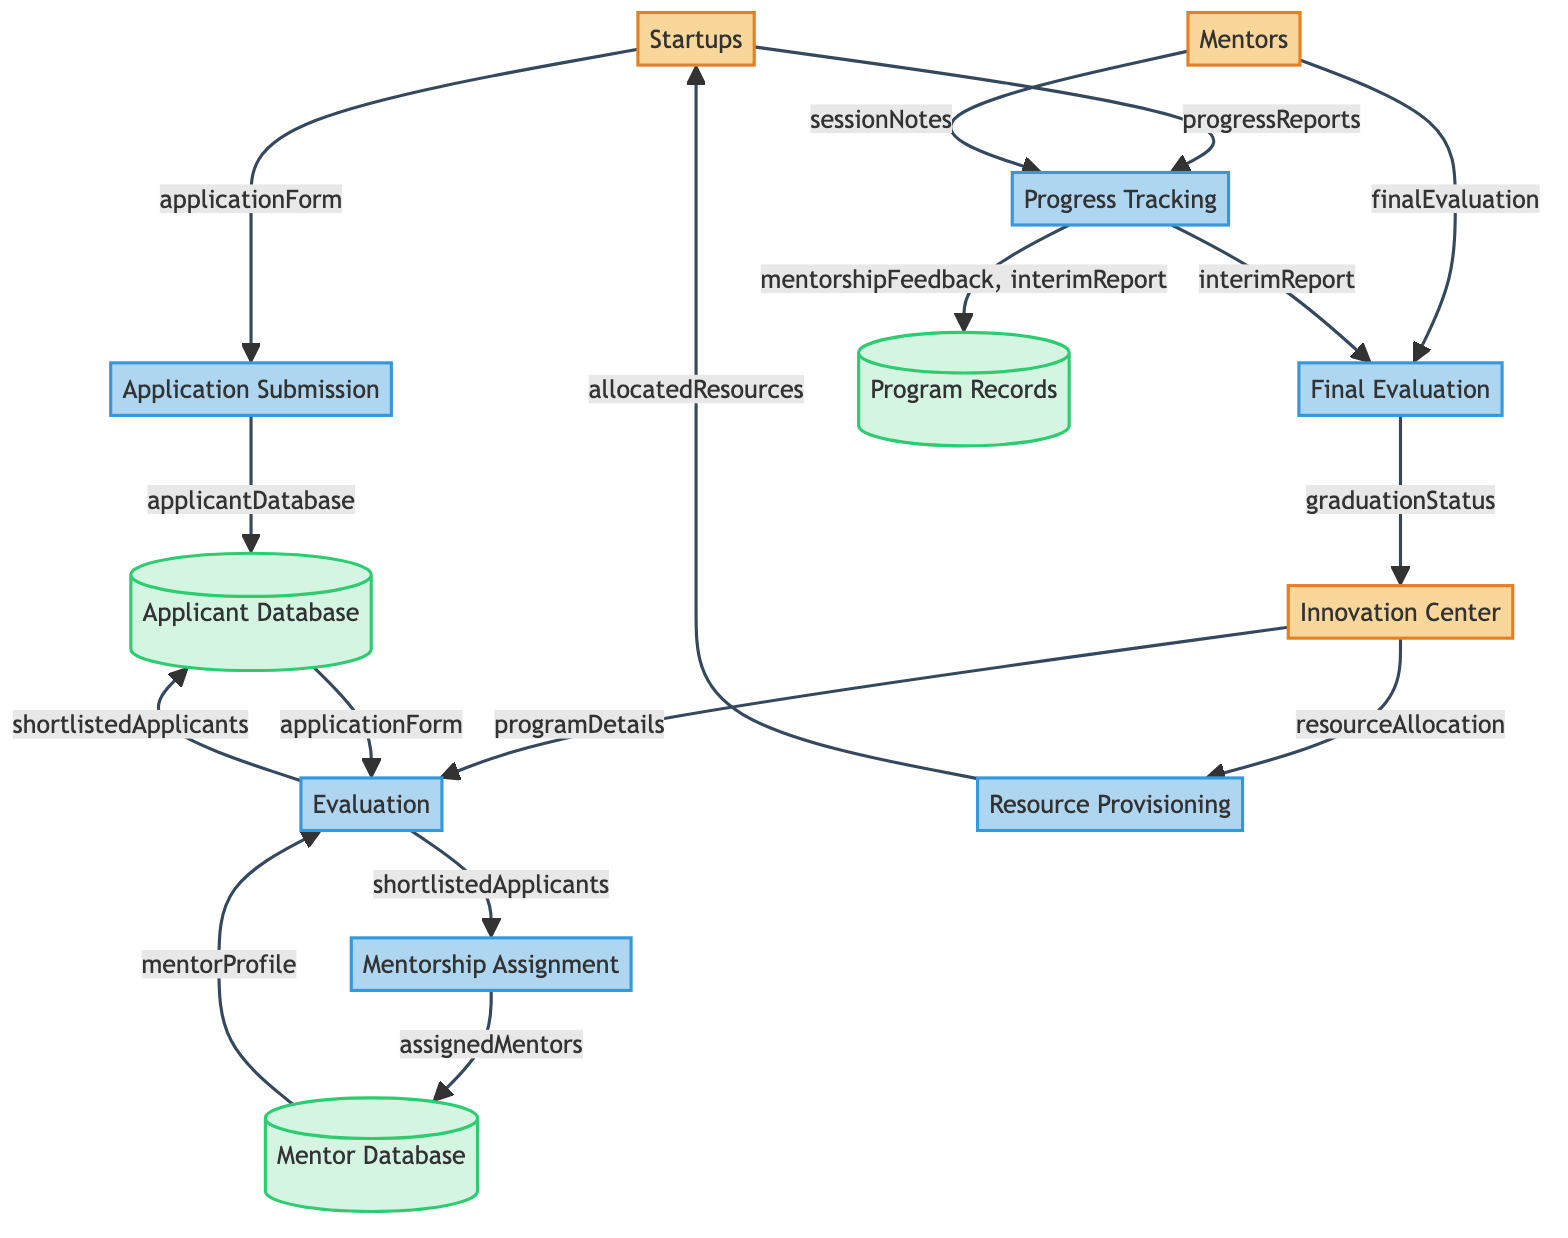How many entities are in the diagram? In the diagram, there are three entities: Startups, Mentors, and Innovation Center.
Answer: 3 What is the output of the Application Submission process? The output of the Application Submission process is the applicant database, which is created from the application form submitted by the startups.
Answer: applicant database Which process receives data from both the Applicant Database and the Mentor Database? The Evaluation process receives inputs from the Applicant Database (application form) and the Mentor Database (mentor profile) to evaluate the applications.
Answer: Evaluation How many processes are involved in the Startup Mentoring Program? There are a total of six processes shown in the diagram: Application Submission, Evaluation, Mentorship Assignment, Progress Tracking, Resource Provisioning, and Final Evaluation.
Answer: 6 What is the final output from the Final Evaluation process? The final output from the Final Evaluation process is the graduation status, which is determined based on the final evaluation and interim report.
Answer: graduation status Which entity provides the program details required for the Evaluation process? The Innovation Center provides the program details that are necessary for conducting the Evaluation process.
Answer: Innovation Center What data is transferred from Progress Tracking to Program Records? The data transferred from Progress Tracking to Program Records includes both mentorship feedback and the interim report generated during the mentoring sessions.
Answer: mentorship feedback, interim report Which process leads to assigning mentors to shortlisted applicants? The Mentorship Assignment process is responsible for assigning mentors to the shortlisted applicants identified in the Evaluation process.
Answer: Mentorship Assignment How are allocated resources provided to Startups? The allocated resources are provided to Startups as an output of the Resource Provisioning process, which receives input from the Innovation Center's resource allocation.
Answer: allocated resources 